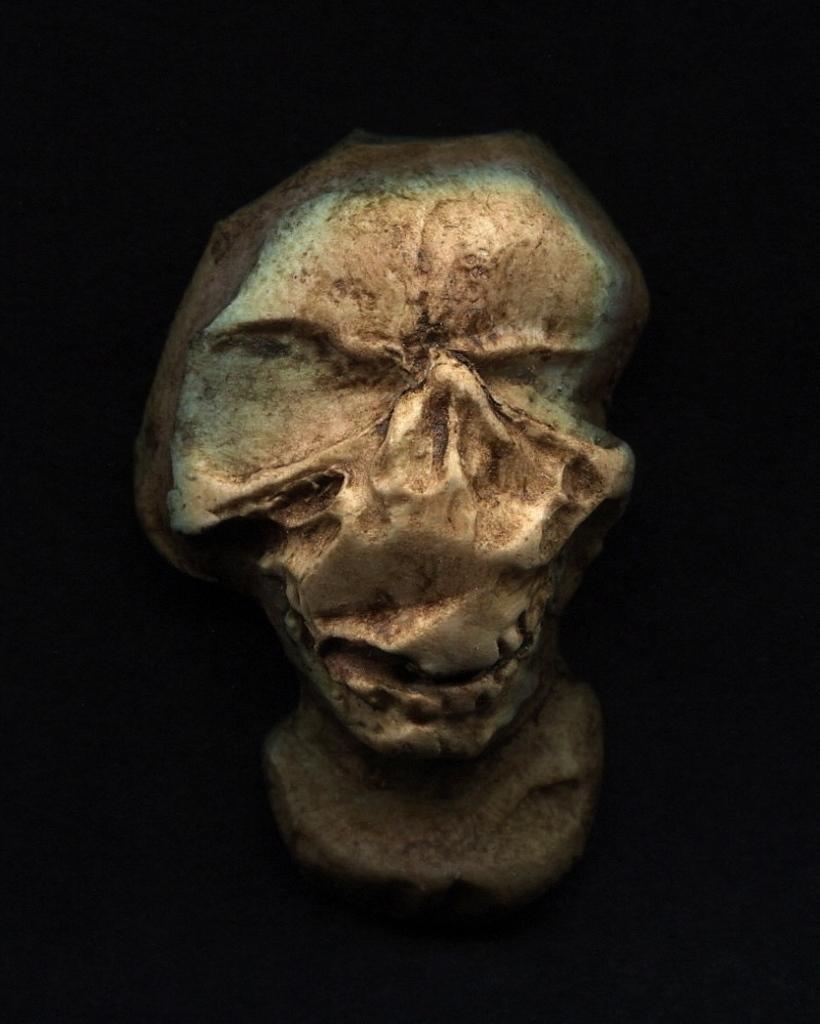In one or two sentences, can you explain what this image depicts? In this image we can see an object, which looks like a skull and the background is dark. 